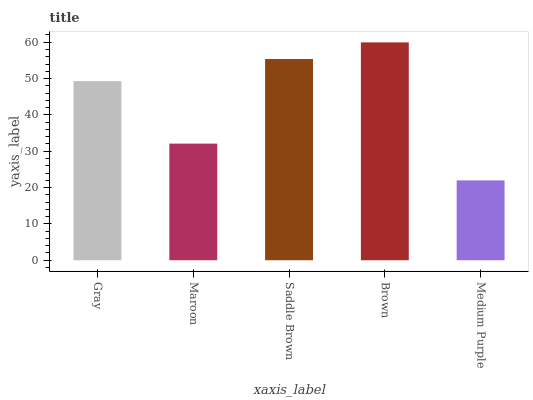Is Medium Purple the minimum?
Answer yes or no. Yes. Is Brown the maximum?
Answer yes or no. Yes. Is Maroon the minimum?
Answer yes or no. No. Is Maroon the maximum?
Answer yes or no. No. Is Gray greater than Maroon?
Answer yes or no. Yes. Is Maroon less than Gray?
Answer yes or no. Yes. Is Maroon greater than Gray?
Answer yes or no. No. Is Gray less than Maroon?
Answer yes or no. No. Is Gray the high median?
Answer yes or no. Yes. Is Gray the low median?
Answer yes or no. Yes. Is Maroon the high median?
Answer yes or no. No. Is Saddle Brown the low median?
Answer yes or no. No. 